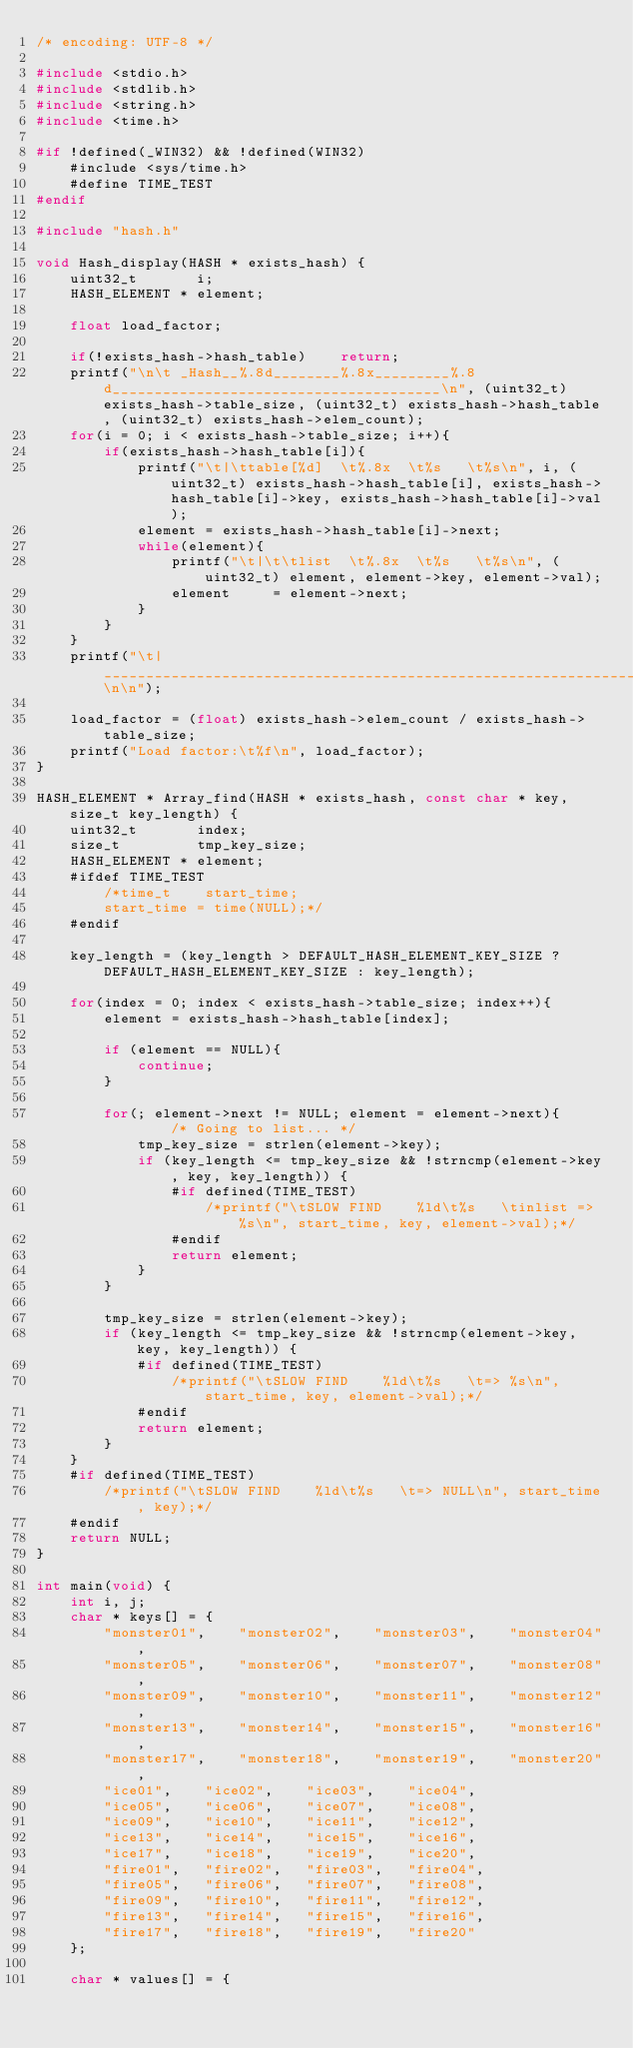Convert code to text. <code><loc_0><loc_0><loc_500><loc_500><_C_>/* encoding: UTF-8 */

#include <stdio.h>
#include <stdlib.h>
#include <string.h>
#include <time.h>

#if !defined(_WIN32) && !defined(WIN32)
	#include <sys/time.h>
	#define TIME_TEST
#endif

#include "hash.h"

void Hash_display(HASH * exists_hash) {
	uint32_t       i;
	HASH_ELEMENT * element;
	
	float load_factor;
	
	if(!exists_hash->hash_table)	return;
	printf("\n\t _Hash__%.8d________%.8x_________%.8d_______________________________________\n", (uint32_t) exists_hash->table_size, (uint32_t) exists_hash->hash_table, (uint32_t) exists_hash->elem_count);
	for(i = 0; i < exists_hash->table_size; i++){
		if(exists_hash->hash_table[i]){
			printf("\t|\ttable[%d]  \t%.8x  \t%s   \t%s\n", i, (uint32_t) exists_hash->hash_table[i], exists_hash->hash_table[i]->key, exists_hash->hash_table[i]->val);
			element = exists_hash->hash_table[i]->next;
			while(element){
				printf("\t|\t\tlist  \t%.8x  \t%s   \t%s\n", (uint32_t) element, element->key, element->val);
				element     = element->next;
			}
		}
	}
	printf("\t|_______________________________________________________________________________________\n\n");
	
	load_factor = (float) exists_hash->elem_count / exists_hash->table_size;
	printf("Load factor:\t%f\n", load_factor);
}

HASH_ELEMENT * Array_find(HASH * exists_hash, const char * key, size_t key_length) {
	uint32_t       index;
	size_t         tmp_key_size;
	HASH_ELEMENT * element;
	#ifdef TIME_TEST
		/*time_t	start_time;
		start_time = time(NULL);*/
	#endif
	
	key_length = (key_length > DEFAULT_HASH_ELEMENT_KEY_SIZE ? DEFAULT_HASH_ELEMENT_KEY_SIZE : key_length);
	
	for(index = 0; index < exists_hash->table_size; index++){
		element = exists_hash->hash_table[index];
		
		if (element == NULL){
			continue;
		}
		
		for(; element->next != NULL; element = element->next){		/* Going to list... */
			tmp_key_size = strlen(element->key);
			if (key_length <= tmp_key_size && !strncmp(element->key, key, key_length)) {
				#if defined(TIME_TEST)
					/*printf("\tSLOW FIND    %ld\t%s   \tinlist => %s\n", start_time, key, element->val);*/
				#endif
				return element;
			}
		}
		
		tmp_key_size = strlen(element->key);
		if (key_length <= tmp_key_size && !strncmp(element->key, key, key_length)) {
			#if defined(TIME_TEST)
				/*printf("\tSLOW FIND    %ld\t%s   \t=> %s\n", start_time, key, element->val);*/
			#endif
			return element;
		}
	}
	#if defined(TIME_TEST)
		/*printf("\tSLOW FIND    %ld\t%s   \t=> NULL\n", start_time, key);*/
	#endif
	return NULL;
}

int main(void) {
	int i, j;
	char * keys[] = {
		"monster01",	"monster02",	"monster03",	"monster04",
		"monster05",	"monster06",	"monster07",	"monster08",
		"monster09",	"monster10",	"monster11",	"monster12",
		"monster13",	"monster14",	"monster15",	"monster16",
		"monster17",	"monster18",	"monster19",	"monster20",
		"ice01",	"ice02",	"ice03",	"ice04",
		"ice05",	"ice06",	"ice07",	"ice08",
		"ice09",	"ice10",	"ice11",	"ice12",
		"ice13",	"ice14",	"ice15",	"ice16",
		"ice17",	"ice18",	"ice19",	"ice20",
		"fire01",	"fire02",	"fire03",	"fire04",
		"fire05",	"fire06",	"fire07",	"fire08",
		"fire09",	"fire10",	"fire11",	"fire12",
		"fire13",	"fire14",	"fire15",	"fire16",
		"fire17",	"fire18",	"fire19",	"fire20"
	};
	
	char * values[] = {</code> 